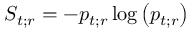<formula> <loc_0><loc_0><loc_500><loc_500>S _ { t ; r } = - p _ { t ; r } \log \left ( p _ { t ; r } \right )</formula> 